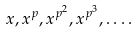Convert formula to latex. <formula><loc_0><loc_0><loc_500><loc_500>x , x ^ { p } , x ^ { p ^ { 2 } } , x ^ { p ^ { 3 } } , \dots .</formula> 